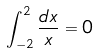Convert formula to latex. <formula><loc_0><loc_0><loc_500><loc_500>\int _ { - 2 } ^ { 2 } \frac { d x } { x } = 0</formula> 